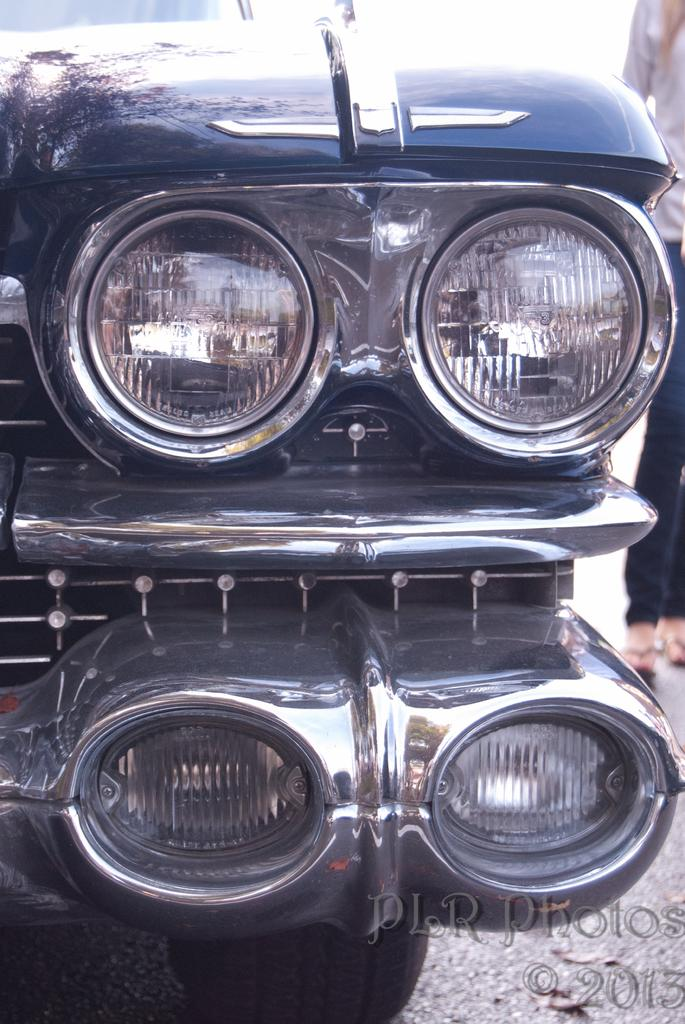What is the main subject of the image? The main subject of the image is a car. What specific features of the car are visible in the image? The car's headlights and bumper are visible in the image. What is the car's position in the image? The car is standing on the ground in the image. Can you describe anything or anyone in the background of the image? There is a person in the background of the image. What is the plot of the number expansion in the image? There is no plot or number expansion present in the image; it features a car with visible headlights and bumper, standing on the ground, and a person in the background. 